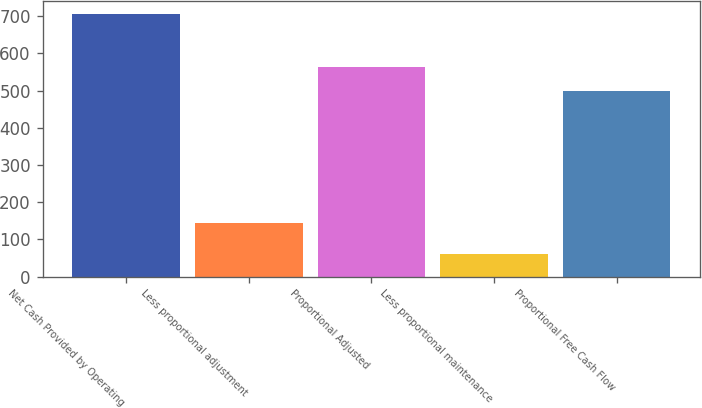Convert chart to OTSL. <chart><loc_0><loc_0><loc_500><loc_500><bar_chart><fcel>Net Cash Provided by Operating<fcel>Less proportional adjustment<fcel>Proportional Adjusted<fcel>Less proportional maintenance<fcel>Proportional Free Cash Flow<nl><fcel>705<fcel>143<fcel>562.4<fcel>61<fcel>498<nl></chart> 